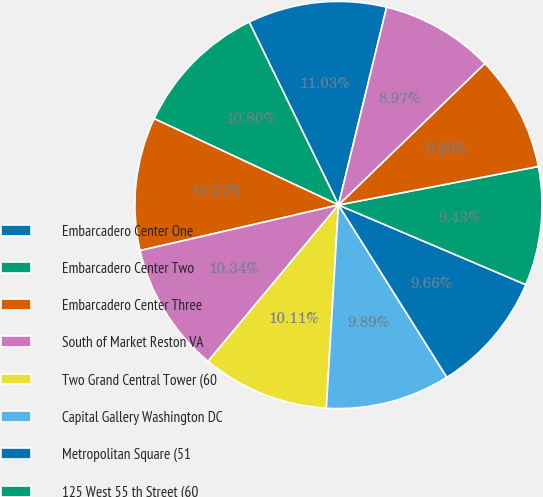Convert chart. <chart><loc_0><loc_0><loc_500><loc_500><pie_chart><fcel>Embarcadero Center One<fcel>Embarcadero Center Two<fcel>Embarcadero Center Three<fcel>South of Market Reston VA<fcel>Two Grand Central Tower (60<fcel>Capital Gallery Washington DC<fcel>Metropolitan Square (51<fcel>125 West 55 th Street (60<fcel>3200 Zanker Road SanJose CA<fcel>901 New York Avenue (25<nl><fcel>11.03%<fcel>10.8%<fcel>10.57%<fcel>10.34%<fcel>10.11%<fcel>9.89%<fcel>9.66%<fcel>9.43%<fcel>9.2%<fcel>8.97%<nl></chart> 